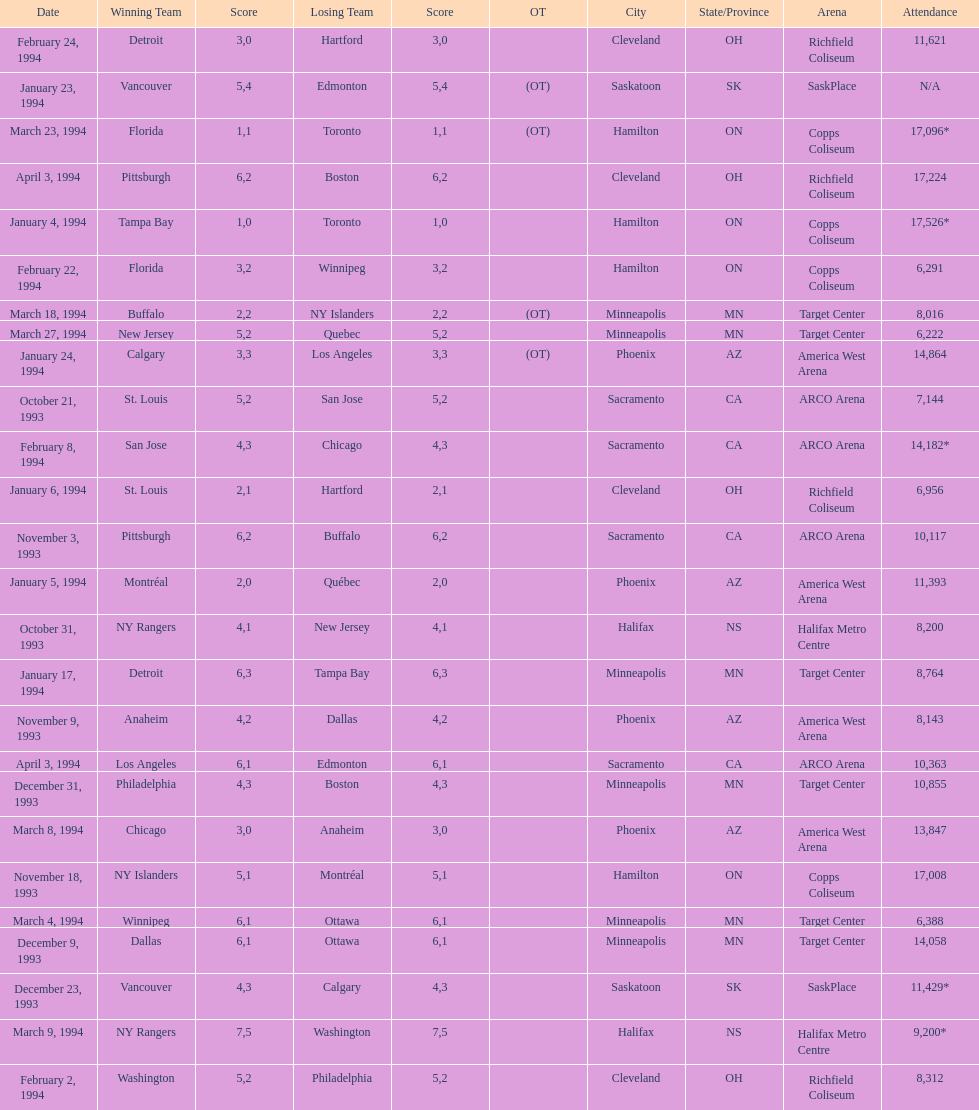Which function had a larger audience, january 24, 1994, or december 23, 1993? January 4, 1994. 